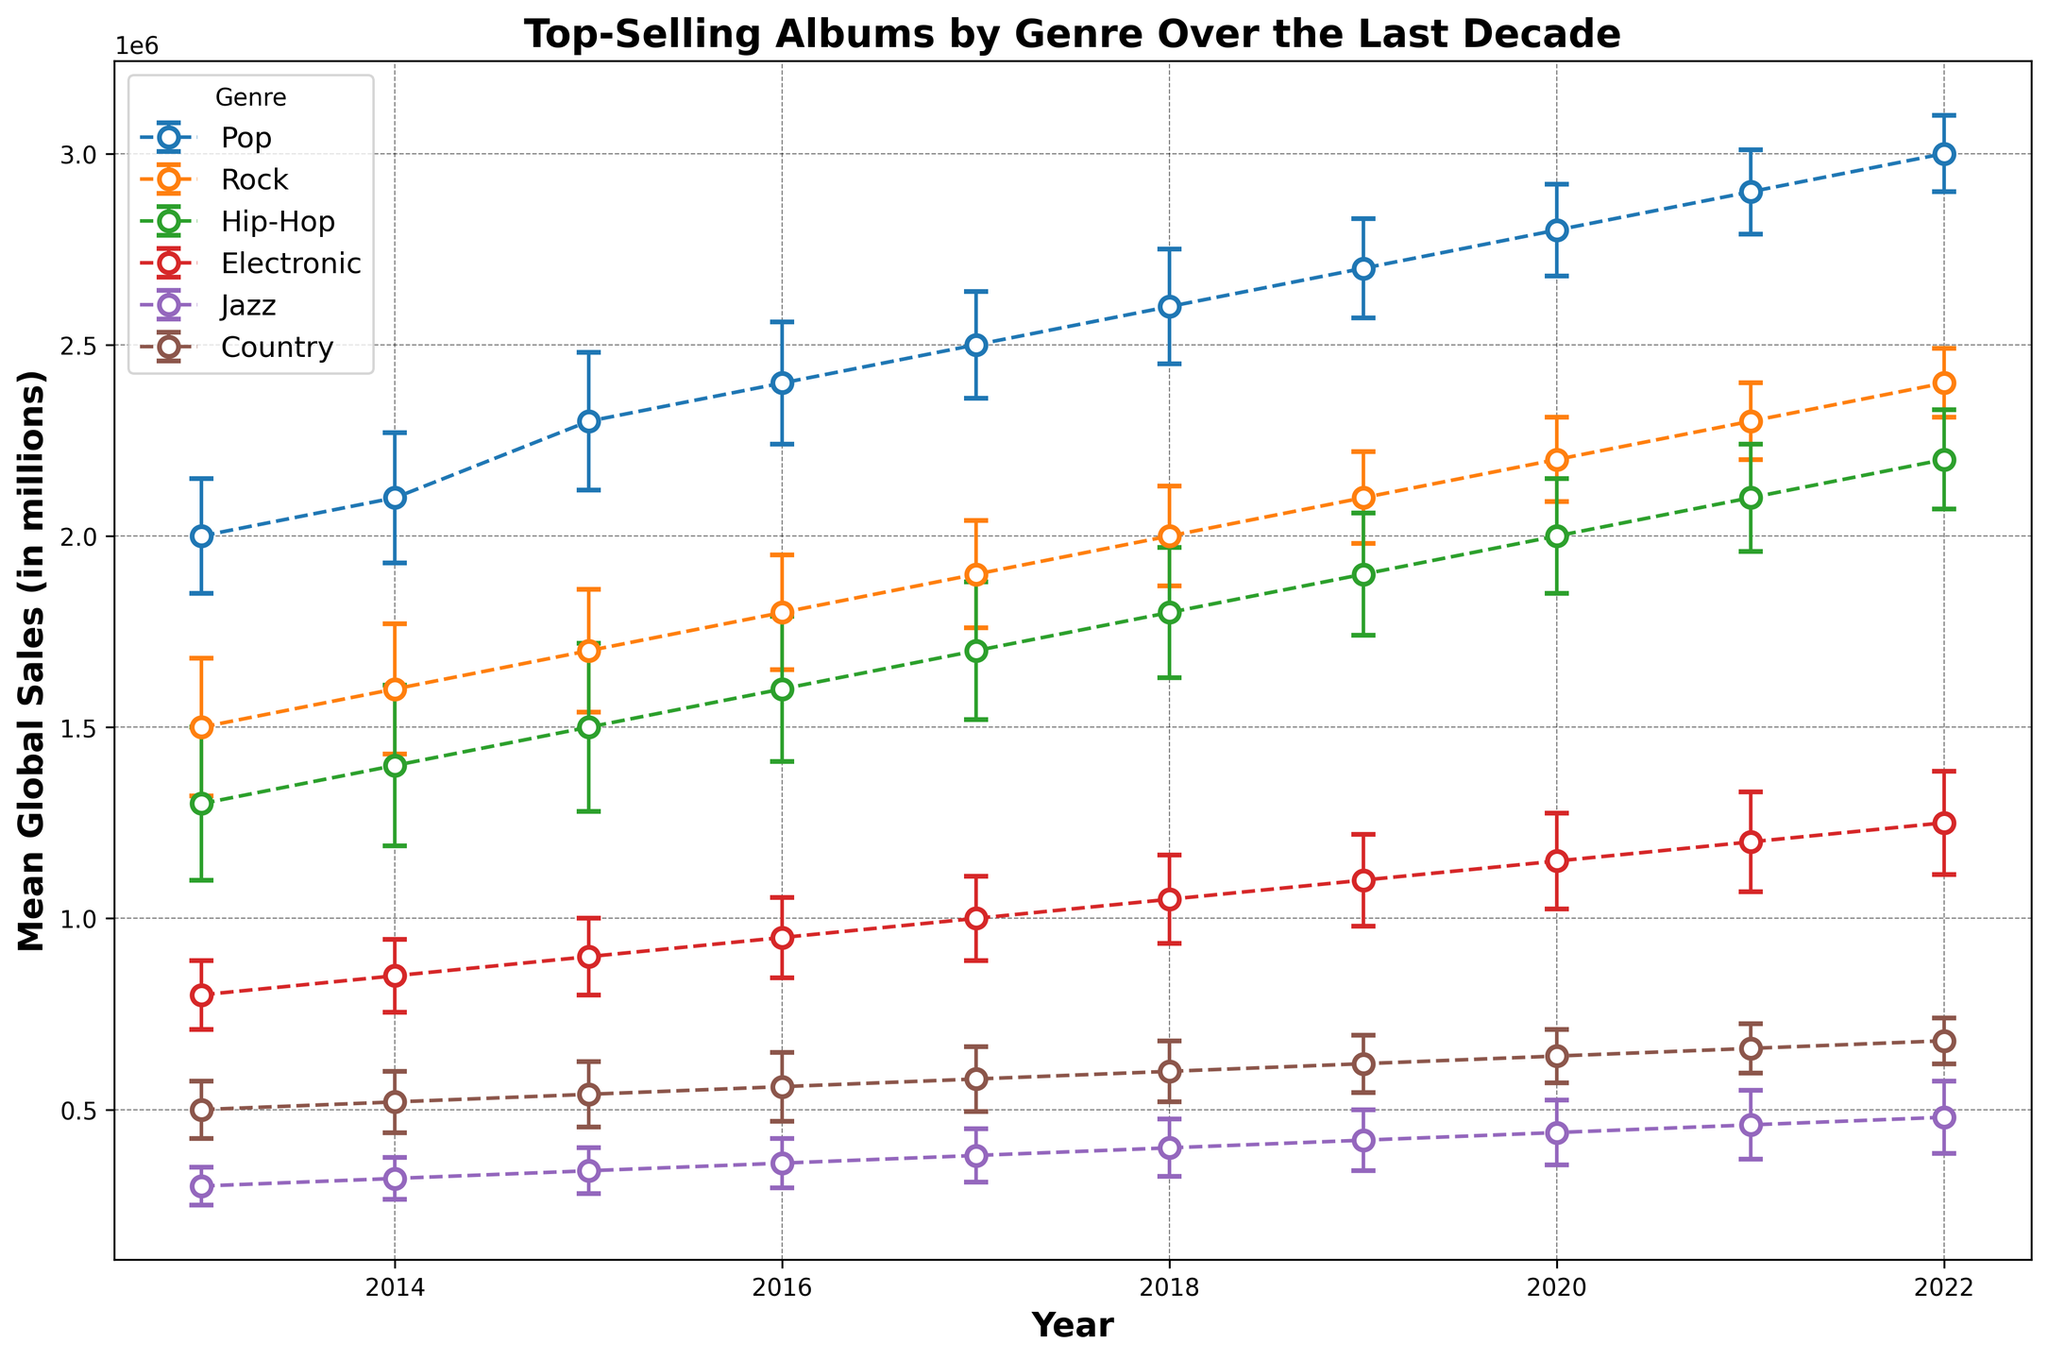What genre had the highest mean global sales in 2022? Look at the error bars in 2022 and find the genre with the highest point. Pop sits at the top.
Answer: Pop Which genre showed the smallest regional sales variation in 2022? Identify the genre with the shortest error bar in 2022. Pop has the shortest error bar, indicating the smallest regional sales variation.
Answer: Pop Between Rock and Hip-Hop, which genre had a greater increase in mean global sales from 2013 to 2022? Calculate the difference in mean sales from 2013 to 2022 for both Rock (2400000 - 1500000 = 900000) and Hip-Hop (2200000 - 1300000 = 900000). Both have the same increase.
Answer: Equal How did the mean global sales of Jazz change from 2013 to 2022? Find the mean global sales for Jazz in 2013 (300000) and 2022 (480000) and subtract the 2013 value from the 2022 value (480000 - 300000 = 180000).
Answer: Increased by 180000 What is the overall trend for Electronic genre sales over the decade? Observe the points connected by lines for the Electronic genre. Electronic shows a steady upward trend from 2013 to 2022.
Answer: Steady upward trend Which year had the maximum regional sales variation for the Hip-Hop genre? Find the longest error bar for Hip-Hop across all years. The longest error bar is in 2015.
Answer: 2015 If you average the regional sales variations of Rock in 2013 and 2022, what do you get? The regional sales variations in 2013 and 2022 are 180000 and 90000, respectively. The average is (180000 + 90000) / 2 = 135000.
Answer: 135000 Compare the sales trends of Pop and Country genres. Which one shows a more consistent regional sales variation over the years? Observe the lengths of error bars from 2013 to 2022 for both genres. Pop has steadily shrinking error bars, while Country's are more fluctuating.
Answer: Pop 